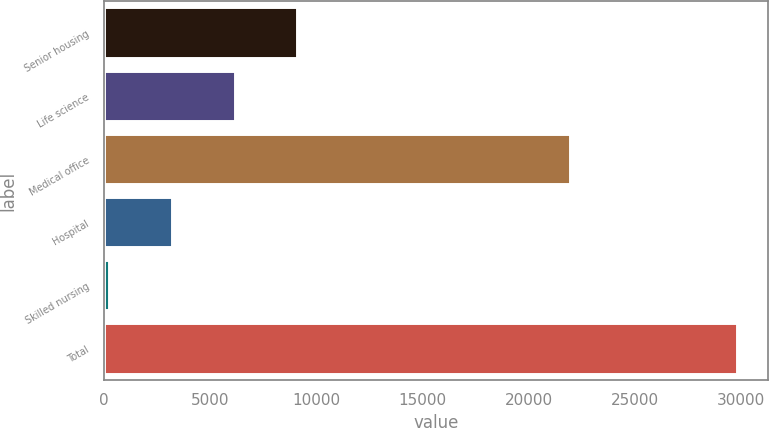Convert chart. <chart><loc_0><loc_0><loc_500><loc_500><bar_chart><fcel>Senior housing<fcel>Life science<fcel>Medical office<fcel>Hospital<fcel>Skilled nursing<fcel>Total<nl><fcel>9101.5<fcel>6143<fcel>21953<fcel>3184.5<fcel>226<fcel>29811<nl></chart> 